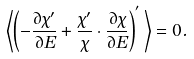<formula> <loc_0><loc_0><loc_500><loc_500>\left < \left ( - \frac { \partial \chi ^ { \prime } } { \partial E } + \frac { \chi ^ { \prime } } { \chi } \cdot \frac { \partial \chi } { \partial E } \right ) ^ { ^ { \prime } } \, \right > = 0 .</formula> 